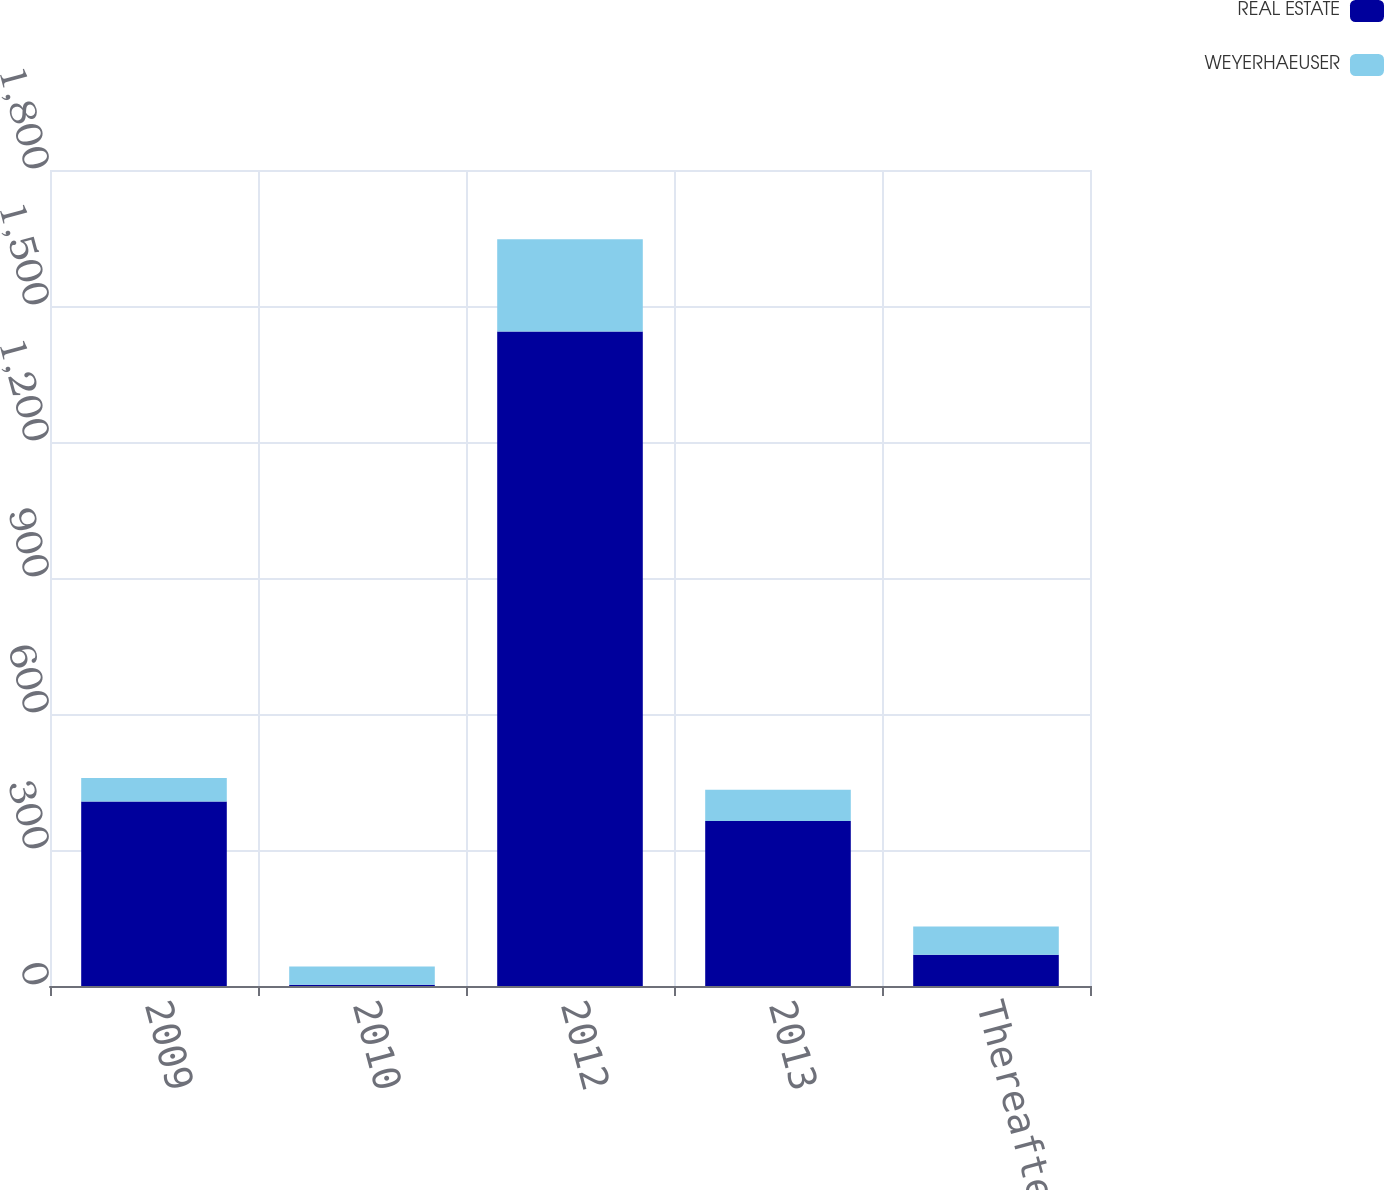Convert chart to OTSL. <chart><loc_0><loc_0><loc_500><loc_500><stacked_bar_chart><ecel><fcel>2009<fcel>2010<fcel>2012<fcel>2013<fcel>Thereafter<nl><fcel>REAL ESTATE<fcel>407<fcel>3<fcel>1444<fcel>364<fcel>69<nl><fcel>WEYERHAEUSER<fcel>52<fcel>40<fcel>203<fcel>69<fcel>62<nl></chart> 